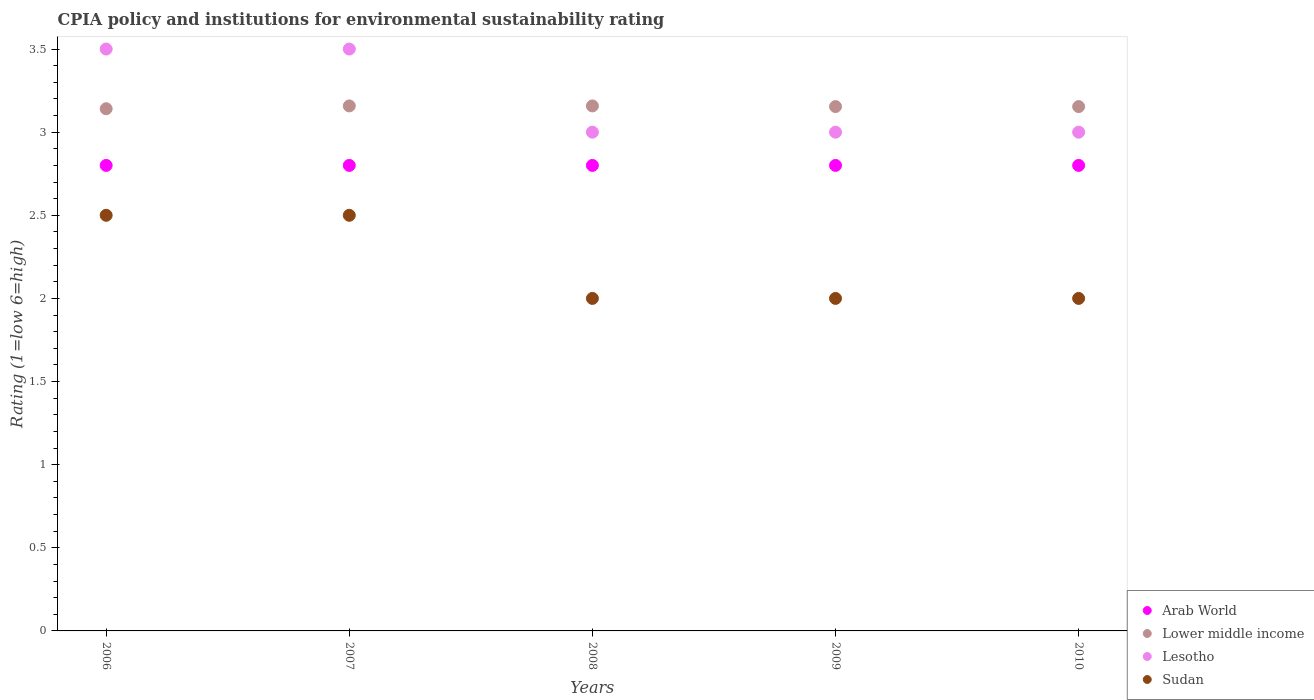Is the number of dotlines equal to the number of legend labels?
Offer a terse response. Yes. What is the CPIA rating in Lower middle income in 2007?
Provide a succinct answer. 3.16. Across all years, what is the minimum CPIA rating in Lower middle income?
Provide a short and direct response. 3.14. In which year was the CPIA rating in Arab World maximum?
Your answer should be compact. 2006. In which year was the CPIA rating in Lower middle income minimum?
Make the answer very short. 2006. What is the total CPIA rating in Lower middle income in the graph?
Your answer should be very brief. 15.76. What is the difference between the CPIA rating in Lesotho in 2008 and the CPIA rating in Arab World in 2009?
Offer a terse response. 0.2. What is the average CPIA rating in Lesotho per year?
Offer a terse response. 3.2. In the year 2007, what is the difference between the CPIA rating in Lesotho and CPIA rating in Arab World?
Provide a succinct answer. 0.7. In how many years, is the CPIA rating in Sudan greater than 2.6?
Your response must be concise. 0. Is the difference between the CPIA rating in Lesotho in 2007 and 2008 greater than the difference between the CPIA rating in Arab World in 2007 and 2008?
Offer a terse response. Yes. What is the difference between the highest and the lowest CPIA rating in Arab World?
Ensure brevity in your answer.  0. Does the CPIA rating in Lower middle income monotonically increase over the years?
Offer a very short reply. No. Is the CPIA rating in Lower middle income strictly less than the CPIA rating in Lesotho over the years?
Offer a very short reply. No. How many dotlines are there?
Offer a very short reply. 4. How many years are there in the graph?
Make the answer very short. 5. Are the values on the major ticks of Y-axis written in scientific E-notation?
Ensure brevity in your answer.  No. Does the graph contain grids?
Your response must be concise. No. How many legend labels are there?
Your answer should be very brief. 4. What is the title of the graph?
Ensure brevity in your answer.  CPIA policy and institutions for environmental sustainability rating. What is the Rating (1=low 6=high) in Arab World in 2006?
Your response must be concise. 2.8. What is the Rating (1=low 6=high) of Lower middle income in 2006?
Ensure brevity in your answer.  3.14. What is the Rating (1=low 6=high) of Lesotho in 2006?
Give a very brief answer. 3.5. What is the Rating (1=low 6=high) of Sudan in 2006?
Your response must be concise. 2.5. What is the Rating (1=low 6=high) in Arab World in 2007?
Provide a short and direct response. 2.8. What is the Rating (1=low 6=high) in Lower middle income in 2007?
Your answer should be very brief. 3.16. What is the Rating (1=low 6=high) of Arab World in 2008?
Ensure brevity in your answer.  2.8. What is the Rating (1=low 6=high) in Lower middle income in 2008?
Give a very brief answer. 3.16. What is the Rating (1=low 6=high) of Sudan in 2008?
Ensure brevity in your answer.  2. What is the Rating (1=low 6=high) in Lower middle income in 2009?
Provide a short and direct response. 3.15. What is the Rating (1=low 6=high) in Lower middle income in 2010?
Offer a terse response. 3.15. What is the Rating (1=low 6=high) in Lesotho in 2010?
Provide a succinct answer. 3. Across all years, what is the maximum Rating (1=low 6=high) in Arab World?
Give a very brief answer. 2.8. Across all years, what is the maximum Rating (1=low 6=high) in Lower middle income?
Your answer should be very brief. 3.16. Across all years, what is the maximum Rating (1=low 6=high) of Lesotho?
Keep it short and to the point. 3.5. Across all years, what is the maximum Rating (1=low 6=high) of Sudan?
Give a very brief answer. 2.5. Across all years, what is the minimum Rating (1=low 6=high) of Arab World?
Make the answer very short. 2.8. Across all years, what is the minimum Rating (1=low 6=high) in Lower middle income?
Make the answer very short. 3.14. Across all years, what is the minimum Rating (1=low 6=high) of Lesotho?
Provide a succinct answer. 3. What is the total Rating (1=low 6=high) of Lower middle income in the graph?
Keep it short and to the point. 15.76. What is the total Rating (1=low 6=high) of Lesotho in the graph?
Offer a very short reply. 16. What is the difference between the Rating (1=low 6=high) in Arab World in 2006 and that in 2007?
Your answer should be very brief. 0. What is the difference between the Rating (1=low 6=high) in Lower middle income in 2006 and that in 2007?
Your response must be concise. -0.02. What is the difference between the Rating (1=low 6=high) in Lesotho in 2006 and that in 2007?
Provide a succinct answer. 0. What is the difference between the Rating (1=low 6=high) in Sudan in 2006 and that in 2007?
Your answer should be very brief. 0. What is the difference between the Rating (1=low 6=high) of Lower middle income in 2006 and that in 2008?
Give a very brief answer. -0.02. What is the difference between the Rating (1=low 6=high) in Sudan in 2006 and that in 2008?
Your answer should be very brief. 0.5. What is the difference between the Rating (1=low 6=high) of Arab World in 2006 and that in 2009?
Offer a very short reply. 0. What is the difference between the Rating (1=low 6=high) of Lower middle income in 2006 and that in 2009?
Your response must be concise. -0.01. What is the difference between the Rating (1=low 6=high) of Lesotho in 2006 and that in 2009?
Keep it short and to the point. 0.5. What is the difference between the Rating (1=low 6=high) in Sudan in 2006 and that in 2009?
Offer a terse response. 0.5. What is the difference between the Rating (1=low 6=high) of Lower middle income in 2006 and that in 2010?
Offer a very short reply. -0.01. What is the difference between the Rating (1=low 6=high) in Lesotho in 2006 and that in 2010?
Offer a very short reply. 0.5. What is the difference between the Rating (1=low 6=high) of Arab World in 2007 and that in 2008?
Provide a succinct answer. 0. What is the difference between the Rating (1=low 6=high) in Lower middle income in 2007 and that in 2008?
Keep it short and to the point. 0. What is the difference between the Rating (1=low 6=high) in Lesotho in 2007 and that in 2008?
Provide a succinct answer. 0.5. What is the difference between the Rating (1=low 6=high) of Sudan in 2007 and that in 2008?
Offer a terse response. 0.5. What is the difference between the Rating (1=low 6=high) of Arab World in 2007 and that in 2009?
Give a very brief answer. 0. What is the difference between the Rating (1=low 6=high) of Lower middle income in 2007 and that in 2009?
Give a very brief answer. 0. What is the difference between the Rating (1=low 6=high) in Lesotho in 2007 and that in 2009?
Offer a terse response. 0.5. What is the difference between the Rating (1=low 6=high) in Lower middle income in 2007 and that in 2010?
Make the answer very short. 0. What is the difference between the Rating (1=low 6=high) of Arab World in 2008 and that in 2009?
Your answer should be very brief. 0. What is the difference between the Rating (1=low 6=high) of Lower middle income in 2008 and that in 2009?
Provide a short and direct response. 0. What is the difference between the Rating (1=low 6=high) in Lesotho in 2008 and that in 2009?
Keep it short and to the point. 0. What is the difference between the Rating (1=low 6=high) of Sudan in 2008 and that in 2009?
Ensure brevity in your answer.  0. What is the difference between the Rating (1=low 6=high) in Arab World in 2008 and that in 2010?
Offer a very short reply. 0. What is the difference between the Rating (1=low 6=high) in Lower middle income in 2008 and that in 2010?
Offer a terse response. 0. What is the difference between the Rating (1=low 6=high) in Lower middle income in 2009 and that in 2010?
Provide a short and direct response. 0. What is the difference between the Rating (1=low 6=high) in Lesotho in 2009 and that in 2010?
Make the answer very short. 0. What is the difference between the Rating (1=low 6=high) in Arab World in 2006 and the Rating (1=low 6=high) in Lower middle income in 2007?
Provide a short and direct response. -0.36. What is the difference between the Rating (1=low 6=high) of Arab World in 2006 and the Rating (1=low 6=high) of Lesotho in 2007?
Your answer should be very brief. -0.7. What is the difference between the Rating (1=low 6=high) in Arab World in 2006 and the Rating (1=low 6=high) in Sudan in 2007?
Your answer should be very brief. 0.3. What is the difference between the Rating (1=low 6=high) of Lower middle income in 2006 and the Rating (1=low 6=high) of Lesotho in 2007?
Your response must be concise. -0.36. What is the difference between the Rating (1=low 6=high) of Lower middle income in 2006 and the Rating (1=low 6=high) of Sudan in 2007?
Your response must be concise. 0.64. What is the difference between the Rating (1=low 6=high) in Arab World in 2006 and the Rating (1=low 6=high) in Lower middle income in 2008?
Provide a succinct answer. -0.36. What is the difference between the Rating (1=low 6=high) in Arab World in 2006 and the Rating (1=low 6=high) in Sudan in 2008?
Provide a short and direct response. 0.8. What is the difference between the Rating (1=low 6=high) in Lower middle income in 2006 and the Rating (1=low 6=high) in Lesotho in 2008?
Provide a short and direct response. 0.14. What is the difference between the Rating (1=low 6=high) in Lower middle income in 2006 and the Rating (1=low 6=high) in Sudan in 2008?
Make the answer very short. 1.14. What is the difference between the Rating (1=low 6=high) in Arab World in 2006 and the Rating (1=low 6=high) in Lower middle income in 2009?
Provide a short and direct response. -0.35. What is the difference between the Rating (1=low 6=high) of Lower middle income in 2006 and the Rating (1=low 6=high) of Lesotho in 2009?
Your answer should be very brief. 0.14. What is the difference between the Rating (1=low 6=high) in Lower middle income in 2006 and the Rating (1=low 6=high) in Sudan in 2009?
Your response must be concise. 1.14. What is the difference between the Rating (1=low 6=high) of Lesotho in 2006 and the Rating (1=low 6=high) of Sudan in 2009?
Ensure brevity in your answer.  1.5. What is the difference between the Rating (1=low 6=high) of Arab World in 2006 and the Rating (1=low 6=high) of Lower middle income in 2010?
Provide a short and direct response. -0.35. What is the difference between the Rating (1=low 6=high) of Lower middle income in 2006 and the Rating (1=low 6=high) of Lesotho in 2010?
Offer a terse response. 0.14. What is the difference between the Rating (1=low 6=high) in Lower middle income in 2006 and the Rating (1=low 6=high) in Sudan in 2010?
Ensure brevity in your answer.  1.14. What is the difference between the Rating (1=low 6=high) of Lesotho in 2006 and the Rating (1=low 6=high) of Sudan in 2010?
Your response must be concise. 1.5. What is the difference between the Rating (1=low 6=high) of Arab World in 2007 and the Rating (1=low 6=high) of Lower middle income in 2008?
Offer a terse response. -0.36. What is the difference between the Rating (1=low 6=high) in Arab World in 2007 and the Rating (1=low 6=high) in Sudan in 2008?
Offer a terse response. 0.8. What is the difference between the Rating (1=low 6=high) in Lower middle income in 2007 and the Rating (1=low 6=high) in Lesotho in 2008?
Keep it short and to the point. 0.16. What is the difference between the Rating (1=low 6=high) of Lower middle income in 2007 and the Rating (1=low 6=high) of Sudan in 2008?
Your answer should be compact. 1.16. What is the difference between the Rating (1=low 6=high) in Arab World in 2007 and the Rating (1=low 6=high) in Lower middle income in 2009?
Ensure brevity in your answer.  -0.35. What is the difference between the Rating (1=low 6=high) of Arab World in 2007 and the Rating (1=low 6=high) of Lesotho in 2009?
Offer a very short reply. -0.2. What is the difference between the Rating (1=low 6=high) of Lower middle income in 2007 and the Rating (1=low 6=high) of Lesotho in 2009?
Your answer should be compact. 0.16. What is the difference between the Rating (1=low 6=high) of Lower middle income in 2007 and the Rating (1=low 6=high) of Sudan in 2009?
Make the answer very short. 1.16. What is the difference between the Rating (1=low 6=high) in Arab World in 2007 and the Rating (1=low 6=high) in Lower middle income in 2010?
Ensure brevity in your answer.  -0.35. What is the difference between the Rating (1=low 6=high) in Arab World in 2007 and the Rating (1=low 6=high) in Lesotho in 2010?
Offer a terse response. -0.2. What is the difference between the Rating (1=low 6=high) in Arab World in 2007 and the Rating (1=low 6=high) in Sudan in 2010?
Offer a terse response. 0.8. What is the difference between the Rating (1=low 6=high) of Lower middle income in 2007 and the Rating (1=low 6=high) of Lesotho in 2010?
Give a very brief answer. 0.16. What is the difference between the Rating (1=low 6=high) of Lower middle income in 2007 and the Rating (1=low 6=high) of Sudan in 2010?
Offer a very short reply. 1.16. What is the difference between the Rating (1=low 6=high) of Arab World in 2008 and the Rating (1=low 6=high) of Lower middle income in 2009?
Keep it short and to the point. -0.35. What is the difference between the Rating (1=low 6=high) of Arab World in 2008 and the Rating (1=low 6=high) of Sudan in 2009?
Offer a very short reply. 0.8. What is the difference between the Rating (1=low 6=high) in Lower middle income in 2008 and the Rating (1=low 6=high) in Lesotho in 2009?
Your response must be concise. 0.16. What is the difference between the Rating (1=low 6=high) of Lower middle income in 2008 and the Rating (1=low 6=high) of Sudan in 2009?
Ensure brevity in your answer.  1.16. What is the difference between the Rating (1=low 6=high) of Arab World in 2008 and the Rating (1=low 6=high) of Lower middle income in 2010?
Your response must be concise. -0.35. What is the difference between the Rating (1=low 6=high) of Arab World in 2008 and the Rating (1=low 6=high) of Lesotho in 2010?
Provide a short and direct response. -0.2. What is the difference between the Rating (1=low 6=high) in Lower middle income in 2008 and the Rating (1=low 6=high) in Lesotho in 2010?
Offer a very short reply. 0.16. What is the difference between the Rating (1=low 6=high) of Lower middle income in 2008 and the Rating (1=low 6=high) of Sudan in 2010?
Ensure brevity in your answer.  1.16. What is the difference between the Rating (1=low 6=high) of Lesotho in 2008 and the Rating (1=low 6=high) of Sudan in 2010?
Keep it short and to the point. 1. What is the difference between the Rating (1=low 6=high) of Arab World in 2009 and the Rating (1=low 6=high) of Lower middle income in 2010?
Keep it short and to the point. -0.35. What is the difference between the Rating (1=low 6=high) of Arab World in 2009 and the Rating (1=low 6=high) of Lesotho in 2010?
Provide a short and direct response. -0.2. What is the difference between the Rating (1=low 6=high) of Lower middle income in 2009 and the Rating (1=low 6=high) of Lesotho in 2010?
Make the answer very short. 0.15. What is the difference between the Rating (1=low 6=high) in Lower middle income in 2009 and the Rating (1=low 6=high) in Sudan in 2010?
Your response must be concise. 1.15. What is the average Rating (1=low 6=high) of Arab World per year?
Offer a very short reply. 2.8. What is the average Rating (1=low 6=high) in Lower middle income per year?
Give a very brief answer. 3.15. In the year 2006, what is the difference between the Rating (1=low 6=high) in Arab World and Rating (1=low 6=high) in Lower middle income?
Give a very brief answer. -0.34. In the year 2006, what is the difference between the Rating (1=low 6=high) in Arab World and Rating (1=low 6=high) in Lesotho?
Provide a succinct answer. -0.7. In the year 2006, what is the difference between the Rating (1=low 6=high) of Arab World and Rating (1=low 6=high) of Sudan?
Ensure brevity in your answer.  0.3. In the year 2006, what is the difference between the Rating (1=low 6=high) of Lower middle income and Rating (1=low 6=high) of Lesotho?
Ensure brevity in your answer.  -0.36. In the year 2006, what is the difference between the Rating (1=low 6=high) of Lower middle income and Rating (1=low 6=high) of Sudan?
Keep it short and to the point. 0.64. In the year 2007, what is the difference between the Rating (1=low 6=high) in Arab World and Rating (1=low 6=high) in Lower middle income?
Give a very brief answer. -0.36. In the year 2007, what is the difference between the Rating (1=low 6=high) of Arab World and Rating (1=low 6=high) of Lesotho?
Provide a short and direct response. -0.7. In the year 2007, what is the difference between the Rating (1=low 6=high) of Lower middle income and Rating (1=low 6=high) of Lesotho?
Your response must be concise. -0.34. In the year 2007, what is the difference between the Rating (1=low 6=high) in Lower middle income and Rating (1=low 6=high) in Sudan?
Keep it short and to the point. 0.66. In the year 2008, what is the difference between the Rating (1=low 6=high) in Arab World and Rating (1=low 6=high) in Lower middle income?
Provide a short and direct response. -0.36. In the year 2008, what is the difference between the Rating (1=low 6=high) in Lower middle income and Rating (1=low 6=high) in Lesotho?
Keep it short and to the point. 0.16. In the year 2008, what is the difference between the Rating (1=low 6=high) of Lower middle income and Rating (1=low 6=high) of Sudan?
Provide a short and direct response. 1.16. In the year 2009, what is the difference between the Rating (1=low 6=high) of Arab World and Rating (1=low 6=high) of Lower middle income?
Offer a terse response. -0.35. In the year 2009, what is the difference between the Rating (1=low 6=high) of Arab World and Rating (1=low 6=high) of Lesotho?
Offer a very short reply. -0.2. In the year 2009, what is the difference between the Rating (1=low 6=high) in Arab World and Rating (1=low 6=high) in Sudan?
Offer a terse response. 0.8. In the year 2009, what is the difference between the Rating (1=low 6=high) in Lower middle income and Rating (1=low 6=high) in Lesotho?
Offer a terse response. 0.15. In the year 2009, what is the difference between the Rating (1=low 6=high) of Lower middle income and Rating (1=low 6=high) of Sudan?
Your response must be concise. 1.15. In the year 2009, what is the difference between the Rating (1=low 6=high) of Lesotho and Rating (1=low 6=high) of Sudan?
Provide a short and direct response. 1. In the year 2010, what is the difference between the Rating (1=low 6=high) of Arab World and Rating (1=low 6=high) of Lower middle income?
Your answer should be very brief. -0.35. In the year 2010, what is the difference between the Rating (1=low 6=high) of Arab World and Rating (1=low 6=high) of Lesotho?
Offer a very short reply. -0.2. In the year 2010, what is the difference between the Rating (1=low 6=high) of Lower middle income and Rating (1=low 6=high) of Lesotho?
Provide a succinct answer. 0.15. In the year 2010, what is the difference between the Rating (1=low 6=high) of Lower middle income and Rating (1=low 6=high) of Sudan?
Offer a very short reply. 1.15. What is the ratio of the Rating (1=low 6=high) in Arab World in 2006 to that in 2007?
Make the answer very short. 1. What is the ratio of the Rating (1=low 6=high) of Lesotho in 2006 to that in 2007?
Your answer should be compact. 1. What is the ratio of the Rating (1=low 6=high) of Arab World in 2006 to that in 2008?
Provide a short and direct response. 1. What is the ratio of the Rating (1=low 6=high) of Sudan in 2006 to that in 2008?
Offer a very short reply. 1.25. What is the ratio of the Rating (1=low 6=high) in Lower middle income in 2006 to that in 2009?
Your answer should be compact. 1. What is the ratio of the Rating (1=low 6=high) of Arab World in 2006 to that in 2010?
Your answer should be very brief. 1. What is the ratio of the Rating (1=low 6=high) of Arab World in 2007 to that in 2008?
Your response must be concise. 1. What is the ratio of the Rating (1=low 6=high) in Lesotho in 2007 to that in 2009?
Provide a short and direct response. 1.17. What is the ratio of the Rating (1=low 6=high) in Lower middle income in 2008 to that in 2009?
Your answer should be compact. 1. What is the ratio of the Rating (1=low 6=high) in Lesotho in 2008 to that in 2009?
Offer a very short reply. 1. What is the ratio of the Rating (1=low 6=high) in Sudan in 2008 to that in 2010?
Provide a succinct answer. 1. What is the ratio of the Rating (1=low 6=high) in Lesotho in 2009 to that in 2010?
Keep it short and to the point. 1. What is the ratio of the Rating (1=low 6=high) of Sudan in 2009 to that in 2010?
Offer a very short reply. 1. What is the difference between the highest and the second highest Rating (1=low 6=high) of Lesotho?
Provide a short and direct response. 0. What is the difference between the highest and the second highest Rating (1=low 6=high) of Sudan?
Provide a short and direct response. 0. What is the difference between the highest and the lowest Rating (1=low 6=high) of Lower middle income?
Your response must be concise. 0.02. What is the difference between the highest and the lowest Rating (1=low 6=high) in Lesotho?
Provide a short and direct response. 0.5. 